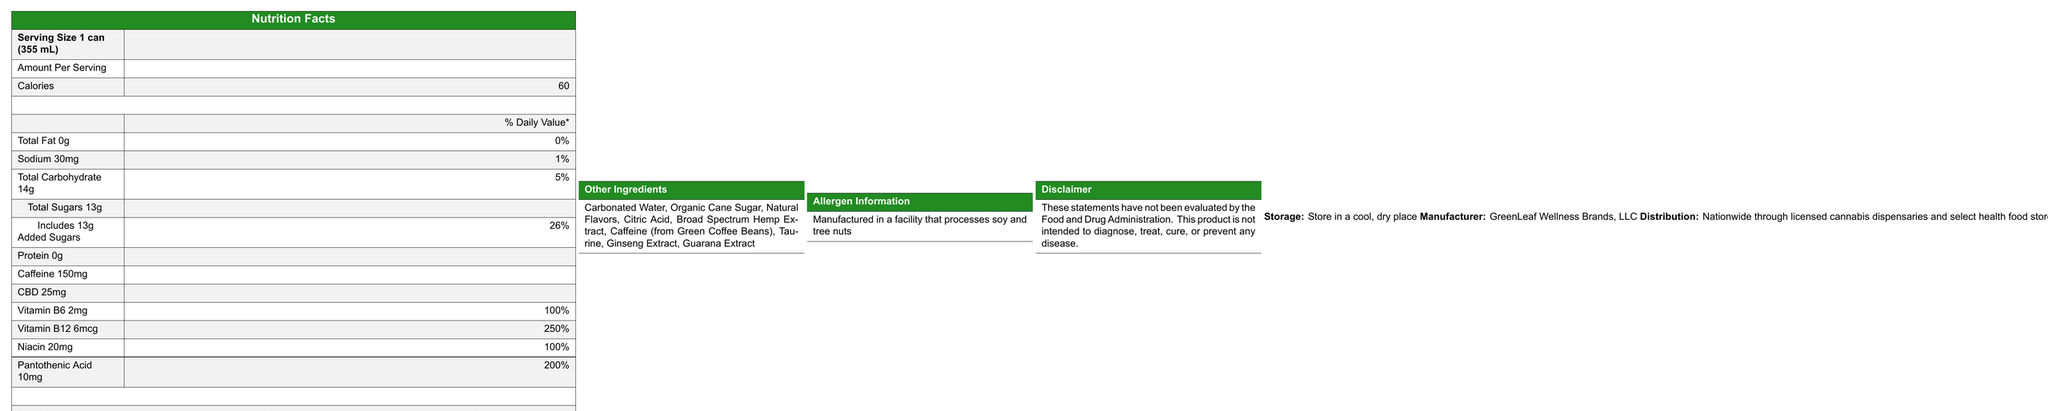what is the serving size? The document indicates that the serving size is 1 can, which is 355 mL.
Answer: 1 can (355 mL) how many calories are in one serving? The Nutrition Facts label specifies that there are 60 calories per serving.
Answer: 60 calories how much caffeine is in the CannaBoost CBD Energy drink? The label states that the drink contains 150mg of caffeine per serving.
Answer: 150mg what is the percentage of the daily value for sodium? The document shows that the sodium content is 30mg, which is 1% of the daily value.
Answer: 1% which vitamins are included in the CannaBoost CBD Energy drink? The label lists Vitamin B6, Vitamin B12, Niacin, and Pantothenic Acid among the vitamins included.
Answer: Vitamin B6, Vitamin B12, Niacin, Pantothenic Acid what is the amount of added sugars in the drink? Under Total Sugars, it specifically mentions that the amount of added sugars is 13g.
Answer: 13g how much Vitamin B12 does one serving contain? The label states that one serving contains 6mcg of Vitamin B12.
Answer: 6mcg What is the daily value percentage for Pantothenic Acid in the drink? According to the document, Pantothenic Acid has a daily value percentage of 200%.
Answer: 200% what are some of the other ingredients listed in the drink? The label lists these as the other ingredients in the drink.
Answer: Carbonated Water, Organic Cane Sugar, Natural Flavors, Citric Acid, Broad Spectrum Hemp Extract, Caffeine (from Green Coffee Beans), Taurine, Ginseng Extract, Guarana Extract who is the manufacturer of the CannaBoost CBD Energy drink? The document indicates that GreenLeaf Wellness Brands, LLC is the manufacturer.
Answer: GreenLeaf Wellness Brands, LLC where is the product available for distribution? The document states that the product is distributed nationwide through licensed cannabis dispensaries and select health food stores.
Answer: Nationwide through licensed cannabis dispensaries and select health food stores how much CBD is in one serving of the drink? The label specifies that there is 25mg of CBD per serving.
Answer: 25mg why should the product be stored in a cool, dry place? The document mentions that the product should be stored in a cool, dry place, which is commonly recommended to maintain the quality and potency of such products.
Answer: To maintain its quality and potency what is the percentage of daily value for Niacin in the energy drink? The document shows that Niacin has a daily value percentage of 100%.
Answer: 100% which statement is true regarding the Fat content in the drink? A. Contains more than 1g of fat B. Contains 0g of fat C. Contains 2g of fat The label states that the drink contains 0g of total fat.
Answer: B. Contains 0g of fat which of the following is not listed as an ingredient? i. Taurine ii. Ascorbic Acid iii. Ginseng Extract The document lists Taurine and Ginseng Extract as ingredients but does not mention Ascorbic Acid.
Answer: ii. Ascorbic Acid is the product intended to diagnose, treat, cure, or prevent any disease? The disclaimer states that these statements have not been evaluated by the Food and Drug Administration and that the product is not intended to diagnose, treat, cure, or prevent any disease.
Answer: No summarize the key details of the CannaBoost CBD Energy drink. This summary covers the essential details such as nutritional content, vitamins, additional ingredients, storage instructions, and distribution channels.
Answer: The CannaBoost CBD Energy drink by GreenLeaf Wellness Brands, LLC is an energy drink with 60 calories, 0g total fat, and 150mg of caffeine per serving. It also contains 25mg of CBD and a variety of vitamins such as Vitamin B6, Vitamin B12, Niacin, and Pantothenic Acid. The product also includes other ingredients like Carbonated Water, Organic Cane Sugar, and Ginseng Extract. It should be stored in a cool, dry place and distributed nationwide through licensed cannabis dispensaries and select health food stores. what are the long-term effects of consuming this CBD energy drink? The document does not provide any information regarding the long-term effects of consuming the CBD energy drink.
Answer: Not enough information 